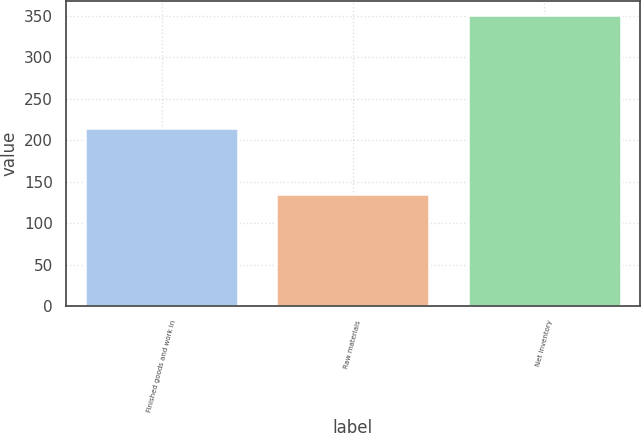<chart> <loc_0><loc_0><loc_500><loc_500><bar_chart><fcel>Finished goods and work in<fcel>Raw materials<fcel>Net inventory<nl><fcel>214.6<fcel>135.9<fcel>350.5<nl></chart> 